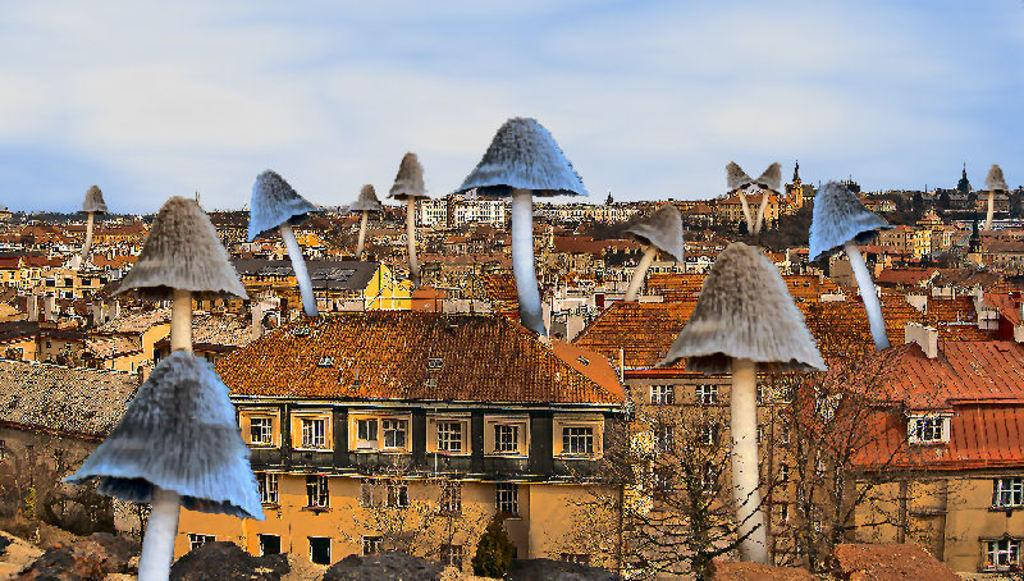What is one of the main elements visible in the image? The sky is one of the main elements visible in the image. What can be seen in the sky in the image? Clouds are present in the image. What type of structures can be seen in the image? There are buildings in the image. What type of vegetation is visible in the image? Mushrooms are visible in the image. Are there any other objects present in the image? Yes, there are a few other objects in the image. What type of song is the robin singing in the image? There is no robin present in the image, so it is not possible to determine what song it might be singing. 